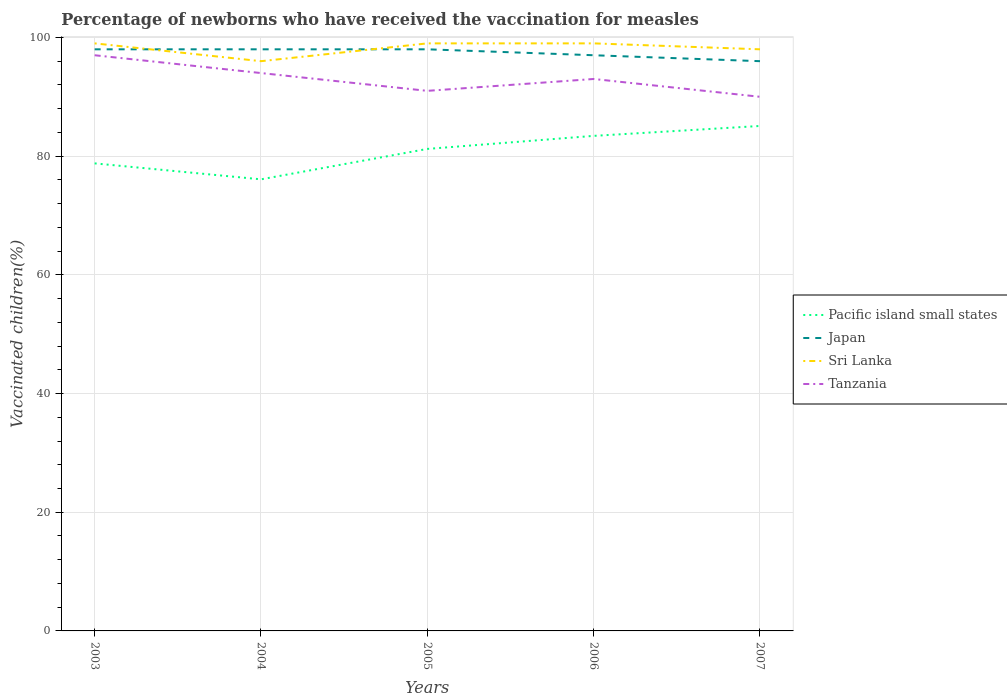How many different coloured lines are there?
Give a very brief answer. 4. Across all years, what is the maximum percentage of vaccinated children in Japan?
Provide a succinct answer. 96. In which year was the percentage of vaccinated children in Japan maximum?
Keep it short and to the point. 2007. What is the total percentage of vaccinated children in Pacific island small states in the graph?
Your answer should be very brief. -8.99. What is the difference between the highest and the second highest percentage of vaccinated children in Pacific island small states?
Your answer should be very brief. 8.99. What is the difference between two consecutive major ticks on the Y-axis?
Provide a short and direct response. 20. Does the graph contain any zero values?
Your answer should be very brief. No. How many legend labels are there?
Your response must be concise. 4. How are the legend labels stacked?
Provide a succinct answer. Vertical. What is the title of the graph?
Your answer should be very brief. Percentage of newborns who have received the vaccination for measles. What is the label or title of the Y-axis?
Ensure brevity in your answer.  Vaccinated children(%). What is the Vaccinated children(%) in Pacific island small states in 2003?
Your answer should be very brief. 78.78. What is the Vaccinated children(%) in Japan in 2003?
Your response must be concise. 98. What is the Vaccinated children(%) of Tanzania in 2003?
Your answer should be compact. 97. What is the Vaccinated children(%) in Pacific island small states in 2004?
Provide a succinct answer. 76.09. What is the Vaccinated children(%) of Sri Lanka in 2004?
Keep it short and to the point. 96. What is the Vaccinated children(%) in Tanzania in 2004?
Your response must be concise. 94. What is the Vaccinated children(%) in Pacific island small states in 2005?
Ensure brevity in your answer.  81.22. What is the Vaccinated children(%) of Sri Lanka in 2005?
Provide a succinct answer. 99. What is the Vaccinated children(%) of Tanzania in 2005?
Your answer should be compact. 91. What is the Vaccinated children(%) of Pacific island small states in 2006?
Your answer should be compact. 83.41. What is the Vaccinated children(%) of Japan in 2006?
Keep it short and to the point. 97. What is the Vaccinated children(%) in Tanzania in 2006?
Make the answer very short. 93. What is the Vaccinated children(%) of Pacific island small states in 2007?
Ensure brevity in your answer.  85.08. What is the Vaccinated children(%) in Japan in 2007?
Your answer should be very brief. 96. What is the Vaccinated children(%) of Sri Lanka in 2007?
Your answer should be compact. 98. Across all years, what is the maximum Vaccinated children(%) in Pacific island small states?
Keep it short and to the point. 85.08. Across all years, what is the maximum Vaccinated children(%) of Tanzania?
Provide a succinct answer. 97. Across all years, what is the minimum Vaccinated children(%) in Pacific island small states?
Provide a short and direct response. 76.09. Across all years, what is the minimum Vaccinated children(%) of Japan?
Keep it short and to the point. 96. Across all years, what is the minimum Vaccinated children(%) of Sri Lanka?
Make the answer very short. 96. What is the total Vaccinated children(%) in Pacific island small states in the graph?
Give a very brief answer. 404.58. What is the total Vaccinated children(%) of Japan in the graph?
Your answer should be compact. 487. What is the total Vaccinated children(%) in Sri Lanka in the graph?
Your response must be concise. 491. What is the total Vaccinated children(%) of Tanzania in the graph?
Provide a short and direct response. 465. What is the difference between the Vaccinated children(%) in Pacific island small states in 2003 and that in 2004?
Give a very brief answer. 2.69. What is the difference between the Vaccinated children(%) in Japan in 2003 and that in 2004?
Offer a very short reply. 0. What is the difference between the Vaccinated children(%) in Pacific island small states in 2003 and that in 2005?
Keep it short and to the point. -2.44. What is the difference between the Vaccinated children(%) of Sri Lanka in 2003 and that in 2005?
Keep it short and to the point. 0. What is the difference between the Vaccinated children(%) in Tanzania in 2003 and that in 2005?
Offer a very short reply. 6. What is the difference between the Vaccinated children(%) in Pacific island small states in 2003 and that in 2006?
Your answer should be compact. -4.63. What is the difference between the Vaccinated children(%) in Japan in 2003 and that in 2006?
Make the answer very short. 1. What is the difference between the Vaccinated children(%) in Tanzania in 2003 and that in 2006?
Give a very brief answer. 4. What is the difference between the Vaccinated children(%) of Pacific island small states in 2003 and that in 2007?
Give a very brief answer. -6.31. What is the difference between the Vaccinated children(%) of Japan in 2003 and that in 2007?
Give a very brief answer. 2. What is the difference between the Vaccinated children(%) in Sri Lanka in 2003 and that in 2007?
Provide a short and direct response. 1. What is the difference between the Vaccinated children(%) in Tanzania in 2003 and that in 2007?
Keep it short and to the point. 7. What is the difference between the Vaccinated children(%) in Pacific island small states in 2004 and that in 2005?
Give a very brief answer. -5.13. What is the difference between the Vaccinated children(%) in Pacific island small states in 2004 and that in 2006?
Your answer should be very brief. -7.32. What is the difference between the Vaccinated children(%) in Pacific island small states in 2004 and that in 2007?
Offer a very short reply. -8.99. What is the difference between the Vaccinated children(%) of Japan in 2004 and that in 2007?
Ensure brevity in your answer.  2. What is the difference between the Vaccinated children(%) in Sri Lanka in 2004 and that in 2007?
Ensure brevity in your answer.  -2. What is the difference between the Vaccinated children(%) of Tanzania in 2004 and that in 2007?
Make the answer very short. 4. What is the difference between the Vaccinated children(%) of Pacific island small states in 2005 and that in 2006?
Ensure brevity in your answer.  -2.2. What is the difference between the Vaccinated children(%) in Tanzania in 2005 and that in 2006?
Make the answer very short. -2. What is the difference between the Vaccinated children(%) in Pacific island small states in 2005 and that in 2007?
Your response must be concise. -3.87. What is the difference between the Vaccinated children(%) of Japan in 2005 and that in 2007?
Provide a succinct answer. 2. What is the difference between the Vaccinated children(%) of Sri Lanka in 2005 and that in 2007?
Your answer should be compact. 1. What is the difference between the Vaccinated children(%) of Pacific island small states in 2006 and that in 2007?
Make the answer very short. -1.67. What is the difference between the Vaccinated children(%) of Sri Lanka in 2006 and that in 2007?
Provide a short and direct response. 1. What is the difference between the Vaccinated children(%) of Pacific island small states in 2003 and the Vaccinated children(%) of Japan in 2004?
Keep it short and to the point. -19.22. What is the difference between the Vaccinated children(%) in Pacific island small states in 2003 and the Vaccinated children(%) in Sri Lanka in 2004?
Offer a very short reply. -17.22. What is the difference between the Vaccinated children(%) in Pacific island small states in 2003 and the Vaccinated children(%) in Tanzania in 2004?
Your response must be concise. -15.22. What is the difference between the Vaccinated children(%) in Japan in 2003 and the Vaccinated children(%) in Tanzania in 2004?
Provide a short and direct response. 4. What is the difference between the Vaccinated children(%) in Pacific island small states in 2003 and the Vaccinated children(%) in Japan in 2005?
Give a very brief answer. -19.22. What is the difference between the Vaccinated children(%) in Pacific island small states in 2003 and the Vaccinated children(%) in Sri Lanka in 2005?
Provide a succinct answer. -20.22. What is the difference between the Vaccinated children(%) of Pacific island small states in 2003 and the Vaccinated children(%) of Tanzania in 2005?
Make the answer very short. -12.22. What is the difference between the Vaccinated children(%) in Sri Lanka in 2003 and the Vaccinated children(%) in Tanzania in 2005?
Your answer should be compact. 8. What is the difference between the Vaccinated children(%) in Pacific island small states in 2003 and the Vaccinated children(%) in Japan in 2006?
Your response must be concise. -18.22. What is the difference between the Vaccinated children(%) of Pacific island small states in 2003 and the Vaccinated children(%) of Sri Lanka in 2006?
Provide a short and direct response. -20.22. What is the difference between the Vaccinated children(%) in Pacific island small states in 2003 and the Vaccinated children(%) in Tanzania in 2006?
Make the answer very short. -14.22. What is the difference between the Vaccinated children(%) in Japan in 2003 and the Vaccinated children(%) in Sri Lanka in 2006?
Ensure brevity in your answer.  -1. What is the difference between the Vaccinated children(%) in Sri Lanka in 2003 and the Vaccinated children(%) in Tanzania in 2006?
Your response must be concise. 6. What is the difference between the Vaccinated children(%) in Pacific island small states in 2003 and the Vaccinated children(%) in Japan in 2007?
Keep it short and to the point. -17.22. What is the difference between the Vaccinated children(%) of Pacific island small states in 2003 and the Vaccinated children(%) of Sri Lanka in 2007?
Provide a succinct answer. -19.22. What is the difference between the Vaccinated children(%) of Pacific island small states in 2003 and the Vaccinated children(%) of Tanzania in 2007?
Offer a very short reply. -11.22. What is the difference between the Vaccinated children(%) in Japan in 2003 and the Vaccinated children(%) in Sri Lanka in 2007?
Your answer should be very brief. 0. What is the difference between the Vaccinated children(%) in Pacific island small states in 2004 and the Vaccinated children(%) in Japan in 2005?
Give a very brief answer. -21.91. What is the difference between the Vaccinated children(%) of Pacific island small states in 2004 and the Vaccinated children(%) of Sri Lanka in 2005?
Provide a short and direct response. -22.91. What is the difference between the Vaccinated children(%) of Pacific island small states in 2004 and the Vaccinated children(%) of Tanzania in 2005?
Give a very brief answer. -14.91. What is the difference between the Vaccinated children(%) in Japan in 2004 and the Vaccinated children(%) in Sri Lanka in 2005?
Your answer should be compact. -1. What is the difference between the Vaccinated children(%) of Sri Lanka in 2004 and the Vaccinated children(%) of Tanzania in 2005?
Give a very brief answer. 5. What is the difference between the Vaccinated children(%) of Pacific island small states in 2004 and the Vaccinated children(%) of Japan in 2006?
Offer a terse response. -20.91. What is the difference between the Vaccinated children(%) in Pacific island small states in 2004 and the Vaccinated children(%) in Sri Lanka in 2006?
Provide a succinct answer. -22.91. What is the difference between the Vaccinated children(%) of Pacific island small states in 2004 and the Vaccinated children(%) of Tanzania in 2006?
Keep it short and to the point. -16.91. What is the difference between the Vaccinated children(%) in Sri Lanka in 2004 and the Vaccinated children(%) in Tanzania in 2006?
Your answer should be compact. 3. What is the difference between the Vaccinated children(%) of Pacific island small states in 2004 and the Vaccinated children(%) of Japan in 2007?
Provide a short and direct response. -19.91. What is the difference between the Vaccinated children(%) in Pacific island small states in 2004 and the Vaccinated children(%) in Sri Lanka in 2007?
Provide a succinct answer. -21.91. What is the difference between the Vaccinated children(%) in Pacific island small states in 2004 and the Vaccinated children(%) in Tanzania in 2007?
Your response must be concise. -13.91. What is the difference between the Vaccinated children(%) of Japan in 2004 and the Vaccinated children(%) of Tanzania in 2007?
Keep it short and to the point. 8. What is the difference between the Vaccinated children(%) of Sri Lanka in 2004 and the Vaccinated children(%) of Tanzania in 2007?
Make the answer very short. 6. What is the difference between the Vaccinated children(%) in Pacific island small states in 2005 and the Vaccinated children(%) in Japan in 2006?
Provide a succinct answer. -15.78. What is the difference between the Vaccinated children(%) in Pacific island small states in 2005 and the Vaccinated children(%) in Sri Lanka in 2006?
Make the answer very short. -17.78. What is the difference between the Vaccinated children(%) in Pacific island small states in 2005 and the Vaccinated children(%) in Tanzania in 2006?
Provide a short and direct response. -11.78. What is the difference between the Vaccinated children(%) in Japan in 2005 and the Vaccinated children(%) in Tanzania in 2006?
Your answer should be compact. 5. What is the difference between the Vaccinated children(%) in Pacific island small states in 2005 and the Vaccinated children(%) in Japan in 2007?
Your answer should be very brief. -14.78. What is the difference between the Vaccinated children(%) of Pacific island small states in 2005 and the Vaccinated children(%) of Sri Lanka in 2007?
Offer a terse response. -16.78. What is the difference between the Vaccinated children(%) of Pacific island small states in 2005 and the Vaccinated children(%) of Tanzania in 2007?
Give a very brief answer. -8.78. What is the difference between the Vaccinated children(%) in Japan in 2005 and the Vaccinated children(%) in Tanzania in 2007?
Keep it short and to the point. 8. What is the difference between the Vaccinated children(%) in Sri Lanka in 2005 and the Vaccinated children(%) in Tanzania in 2007?
Your answer should be very brief. 9. What is the difference between the Vaccinated children(%) of Pacific island small states in 2006 and the Vaccinated children(%) of Japan in 2007?
Keep it short and to the point. -12.59. What is the difference between the Vaccinated children(%) of Pacific island small states in 2006 and the Vaccinated children(%) of Sri Lanka in 2007?
Offer a terse response. -14.59. What is the difference between the Vaccinated children(%) in Pacific island small states in 2006 and the Vaccinated children(%) in Tanzania in 2007?
Provide a succinct answer. -6.59. What is the difference between the Vaccinated children(%) of Japan in 2006 and the Vaccinated children(%) of Tanzania in 2007?
Offer a terse response. 7. What is the difference between the Vaccinated children(%) of Sri Lanka in 2006 and the Vaccinated children(%) of Tanzania in 2007?
Ensure brevity in your answer.  9. What is the average Vaccinated children(%) of Pacific island small states per year?
Your answer should be compact. 80.92. What is the average Vaccinated children(%) of Japan per year?
Keep it short and to the point. 97.4. What is the average Vaccinated children(%) of Sri Lanka per year?
Offer a terse response. 98.2. What is the average Vaccinated children(%) in Tanzania per year?
Ensure brevity in your answer.  93. In the year 2003, what is the difference between the Vaccinated children(%) of Pacific island small states and Vaccinated children(%) of Japan?
Offer a terse response. -19.22. In the year 2003, what is the difference between the Vaccinated children(%) in Pacific island small states and Vaccinated children(%) in Sri Lanka?
Make the answer very short. -20.22. In the year 2003, what is the difference between the Vaccinated children(%) in Pacific island small states and Vaccinated children(%) in Tanzania?
Provide a succinct answer. -18.22. In the year 2003, what is the difference between the Vaccinated children(%) in Japan and Vaccinated children(%) in Sri Lanka?
Keep it short and to the point. -1. In the year 2003, what is the difference between the Vaccinated children(%) in Japan and Vaccinated children(%) in Tanzania?
Your answer should be compact. 1. In the year 2003, what is the difference between the Vaccinated children(%) in Sri Lanka and Vaccinated children(%) in Tanzania?
Your response must be concise. 2. In the year 2004, what is the difference between the Vaccinated children(%) of Pacific island small states and Vaccinated children(%) of Japan?
Offer a very short reply. -21.91. In the year 2004, what is the difference between the Vaccinated children(%) of Pacific island small states and Vaccinated children(%) of Sri Lanka?
Keep it short and to the point. -19.91. In the year 2004, what is the difference between the Vaccinated children(%) of Pacific island small states and Vaccinated children(%) of Tanzania?
Ensure brevity in your answer.  -17.91. In the year 2004, what is the difference between the Vaccinated children(%) in Sri Lanka and Vaccinated children(%) in Tanzania?
Your response must be concise. 2. In the year 2005, what is the difference between the Vaccinated children(%) of Pacific island small states and Vaccinated children(%) of Japan?
Your answer should be compact. -16.78. In the year 2005, what is the difference between the Vaccinated children(%) in Pacific island small states and Vaccinated children(%) in Sri Lanka?
Ensure brevity in your answer.  -17.78. In the year 2005, what is the difference between the Vaccinated children(%) in Pacific island small states and Vaccinated children(%) in Tanzania?
Your answer should be very brief. -9.78. In the year 2005, what is the difference between the Vaccinated children(%) of Japan and Vaccinated children(%) of Tanzania?
Your answer should be very brief. 7. In the year 2005, what is the difference between the Vaccinated children(%) in Sri Lanka and Vaccinated children(%) in Tanzania?
Make the answer very short. 8. In the year 2006, what is the difference between the Vaccinated children(%) in Pacific island small states and Vaccinated children(%) in Japan?
Your answer should be very brief. -13.59. In the year 2006, what is the difference between the Vaccinated children(%) of Pacific island small states and Vaccinated children(%) of Sri Lanka?
Ensure brevity in your answer.  -15.59. In the year 2006, what is the difference between the Vaccinated children(%) in Pacific island small states and Vaccinated children(%) in Tanzania?
Give a very brief answer. -9.59. In the year 2006, what is the difference between the Vaccinated children(%) of Japan and Vaccinated children(%) of Sri Lanka?
Offer a very short reply. -2. In the year 2006, what is the difference between the Vaccinated children(%) of Sri Lanka and Vaccinated children(%) of Tanzania?
Keep it short and to the point. 6. In the year 2007, what is the difference between the Vaccinated children(%) of Pacific island small states and Vaccinated children(%) of Japan?
Provide a succinct answer. -10.92. In the year 2007, what is the difference between the Vaccinated children(%) of Pacific island small states and Vaccinated children(%) of Sri Lanka?
Ensure brevity in your answer.  -12.92. In the year 2007, what is the difference between the Vaccinated children(%) in Pacific island small states and Vaccinated children(%) in Tanzania?
Keep it short and to the point. -4.92. In the year 2007, what is the difference between the Vaccinated children(%) of Sri Lanka and Vaccinated children(%) of Tanzania?
Offer a very short reply. 8. What is the ratio of the Vaccinated children(%) of Pacific island small states in 2003 to that in 2004?
Ensure brevity in your answer.  1.04. What is the ratio of the Vaccinated children(%) of Sri Lanka in 2003 to that in 2004?
Offer a terse response. 1.03. What is the ratio of the Vaccinated children(%) in Tanzania in 2003 to that in 2004?
Offer a terse response. 1.03. What is the ratio of the Vaccinated children(%) of Pacific island small states in 2003 to that in 2005?
Make the answer very short. 0.97. What is the ratio of the Vaccinated children(%) of Sri Lanka in 2003 to that in 2005?
Offer a very short reply. 1. What is the ratio of the Vaccinated children(%) in Tanzania in 2003 to that in 2005?
Ensure brevity in your answer.  1.07. What is the ratio of the Vaccinated children(%) in Japan in 2003 to that in 2006?
Keep it short and to the point. 1.01. What is the ratio of the Vaccinated children(%) of Tanzania in 2003 to that in 2006?
Your answer should be very brief. 1.04. What is the ratio of the Vaccinated children(%) in Pacific island small states in 2003 to that in 2007?
Your response must be concise. 0.93. What is the ratio of the Vaccinated children(%) in Japan in 2003 to that in 2007?
Give a very brief answer. 1.02. What is the ratio of the Vaccinated children(%) of Sri Lanka in 2003 to that in 2007?
Give a very brief answer. 1.01. What is the ratio of the Vaccinated children(%) in Tanzania in 2003 to that in 2007?
Offer a very short reply. 1.08. What is the ratio of the Vaccinated children(%) of Pacific island small states in 2004 to that in 2005?
Provide a succinct answer. 0.94. What is the ratio of the Vaccinated children(%) of Japan in 2004 to that in 2005?
Give a very brief answer. 1. What is the ratio of the Vaccinated children(%) of Sri Lanka in 2004 to that in 2005?
Your answer should be very brief. 0.97. What is the ratio of the Vaccinated children(%) of Tanzania in 2004 to that in 2005?
Give a very brief answer. 1.03. What is the ratio of the Vaccinated children(%) in Pacific island small states in 2004 to that in 2006?
Provide a short and direct response. 0.91. What is the ratio of the Vaccinated children(%) in Japan in 2004 to that in 2006?
Your answer should be very brief. 1.01. What is the ratio of the Vaccinated children(%) in Sri Lanka in 2004 to that in 2006?
Keep it short and to the point. 0.97. What is the ratio of the Vaccinated children(%) in Tanzania in 2004 to that in 2006?
Your response must be concise. 1.01. What is the ratio of the Vaccinated children(%) in Pacific island small states in 2004 to that in 2007?
Your answer should be very brief. 0.89. What is the ratio of the Vaccinated children(%) in Japan in 2004 to that in 2007?
Your answer should be very brief. 1.02. What is the ratio of the Vaccinated children(%) of Sri Lanka in 2004 to that in 2007?
Give a very brief answer. 0.98. What is the ratio of the Vaccinated children(%) of Tanzania in 2004 to that in 2007?
Provide a short and direct response. 1.04. What is the ratio of the Vaccinated children(%) in Pacific island small states in 2005 to that in 2006?
Your response must be concise. 0.97. What is the ratio of the Vaccinated children(%) of Japan in 2005 to that in 2006?
Your response must be concise. 1.01. What is the ratio of the Vaccinated children(%) in Tanzania in 2005 to that in 2006?
Give a very brief answer. 0.98. What is the ratio of the Vaccinated children(%) in Pacific island small states in 2005 to that in 2007?
Your response must be concise. 0.95. What is the ratio of the Vaccinated children(%) in Japan in 2005 to that in 2007?
Ensure brevity in your answer.  1.02. What is the ratio of the Vaccinated children(%) in Sri Lanka in 2005 to that in 2007?
Offer a very short reply. 1.01. What is the ratio of the Vaccinated children(%) of Tanzania in 2005 to that in 2007?
Your response must be concise. 1.01. What is the ratio of the Vaccinated children(%) of Pacific island small states in 2006 to that in 2007?
Your answer should be very brief. 0.98. What is the ratio of the Vaccinated children(%) in Japan in 2006 to that in 2007?
Provide a short and direct response. 1.01. What is the ratio of the Vaccinated children(%) in Sri Lanka in 2006 to that in 2007?
Keep it short and to the point. 1.01. What is the ratio of the Vaccinated children(%) of Tanzania in 2006 to that in 2007?
Provide a short and direct response. 1.03. What is the difference between the highest and the second highest Vaccinated children(%) of Pacific island small states?
Provide a succinct answer. 1.67. What is the difference between the highest and the second highest Vaccinated children(%) of Sri Lanka?
Ensure brevity in your answer.  0. What is the difference between the highest and the lowest Vaccinated children(%) of Pacific island small states?
Make the answer very short. 8.99. What is the difference between the highest and the lowest Vaccinated children(%) in Sri Lanka?
Provide a short and direct response. 3. What is the difference between the highest and the lowest Vaccinated children(%) in Tanzania?
Your answer should be compact. 7. 